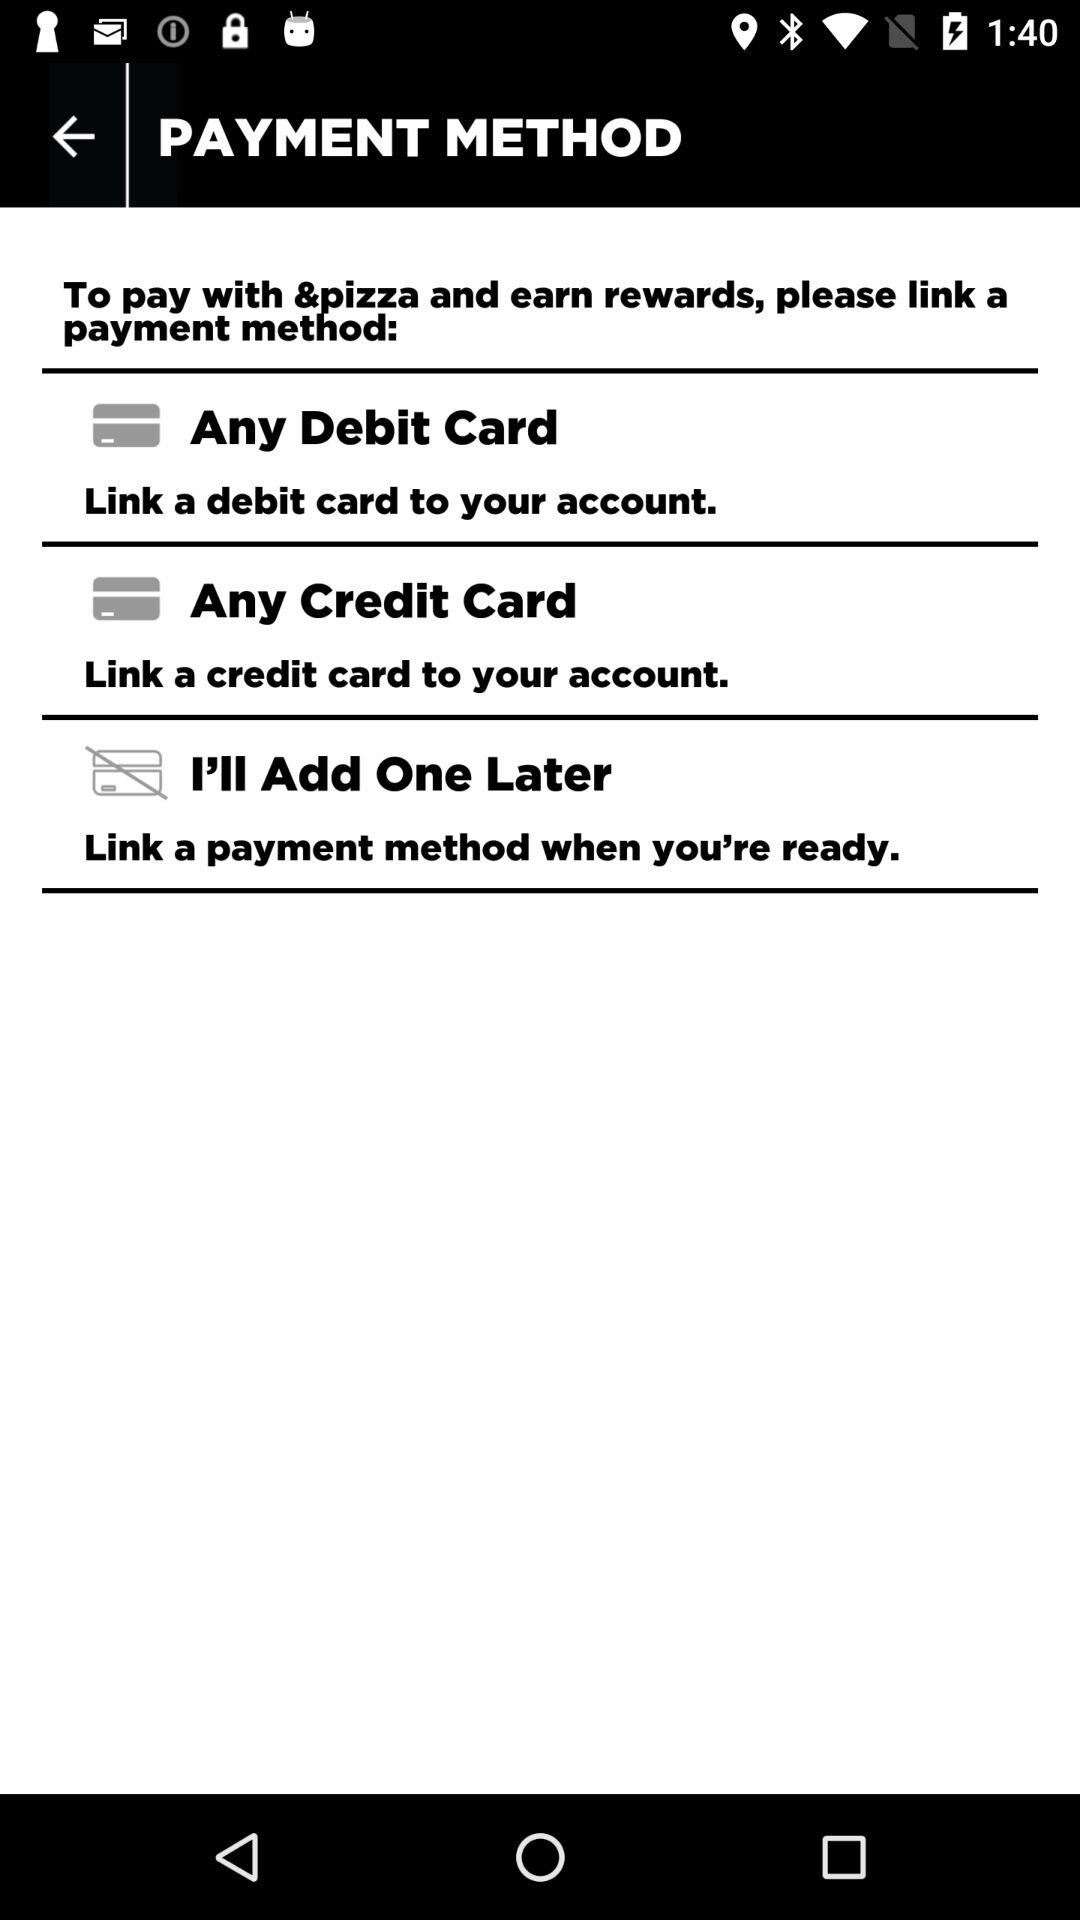How many payment methods are available to add?
Answer the question using a single word or phrase. 3 